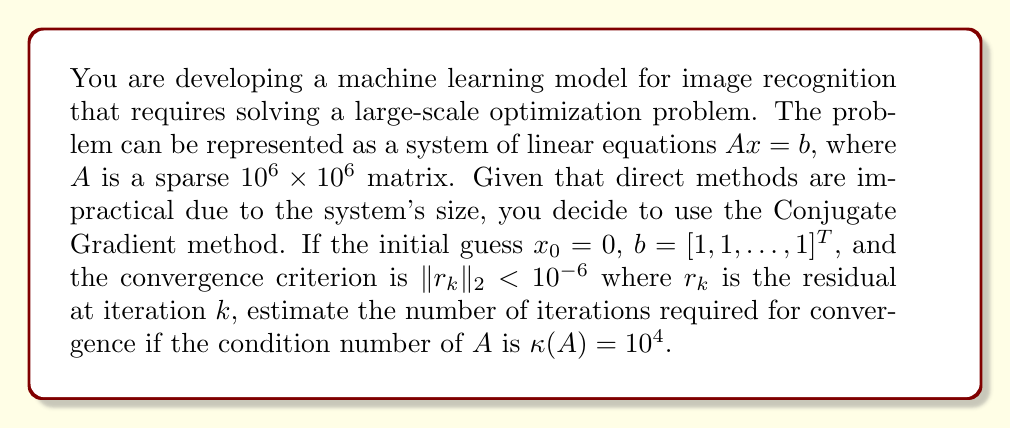Solve this math problem. To estimate the number of iterations required for the Conjugate Gradient method to converge, we can use the following steps:

1) The Conjugate Gradient method is an iterative method for solving symmetric positive definite systems. Its convergence rate is related to the condition number of the matrix $A$.

2) For a symmetric positive definite matrix $A$, the error at the $k$-th iteration of the Conjugate Gradient method satisfies:

   $$\|x_k - x^*\|_A \leq 2 \left(\frac{\sqrt{\kappa(A)} - 1}{\sqrt{\kappa(A)} + 1}\right)^k \|x_0 - x^*\|_A$$

   where $x^*$ is the exact solution, and $\|v\|_A = \sqrt{v^TAv}$ is the $A$-norm.

3) We can relate this to the residual norm using:

   $$\|r_k\|_2 \leq \|A\| \|x_k - x^*\|_A$$

4) Combining these inequalities and using the given convergence criterion:

   $$10^{-6} > \|r_k\|_2 \leq \|A\| \cdot 2 \left(\frac{\sqrt{\kappa(A)} - 1}{\sqrt{\kappa(A)} + 1}\right)^k \|x_0 - x^*\|_A$$

5) Taking logarithms and solving for $k$:

   $$k > \frac{\log(\frac{10^{-6}}{2\|A\| \|x_0 - x^*\|_A})}{\log(\frac{\sqrt{\kappa(A)} - 1}{\sqrt{\kappa(A)} + 1})}$$

6) We're given that $\kappa(A) = 10^4$. Substituting this:

   $$k > \frac{\log(\frac{10^{-6}}{2\|A\| \|x_0 - x^*\|_A})}{\log(\frac{\sqrt{10^4} - 1}{\sqrt{10^4} + 1})} \approx 631.64 \cdot \log(\frac{2\|A\| \|x_0 - x^*\|_A}{10^{-6}})$$

7) The term $\|A\| \|x_0 - x^*\|_A$ depends on the specific problem and initial guess. However, given that $x_0 = 0$ and $b$ is a vector of ones, we can estimate this term to be of order 1.

Therefore, we can estimate that the number of iterations required will be approximately 632.
Answer: The Conjugate Gradient method will require approximately 632 iterations to converge for the given problem. 